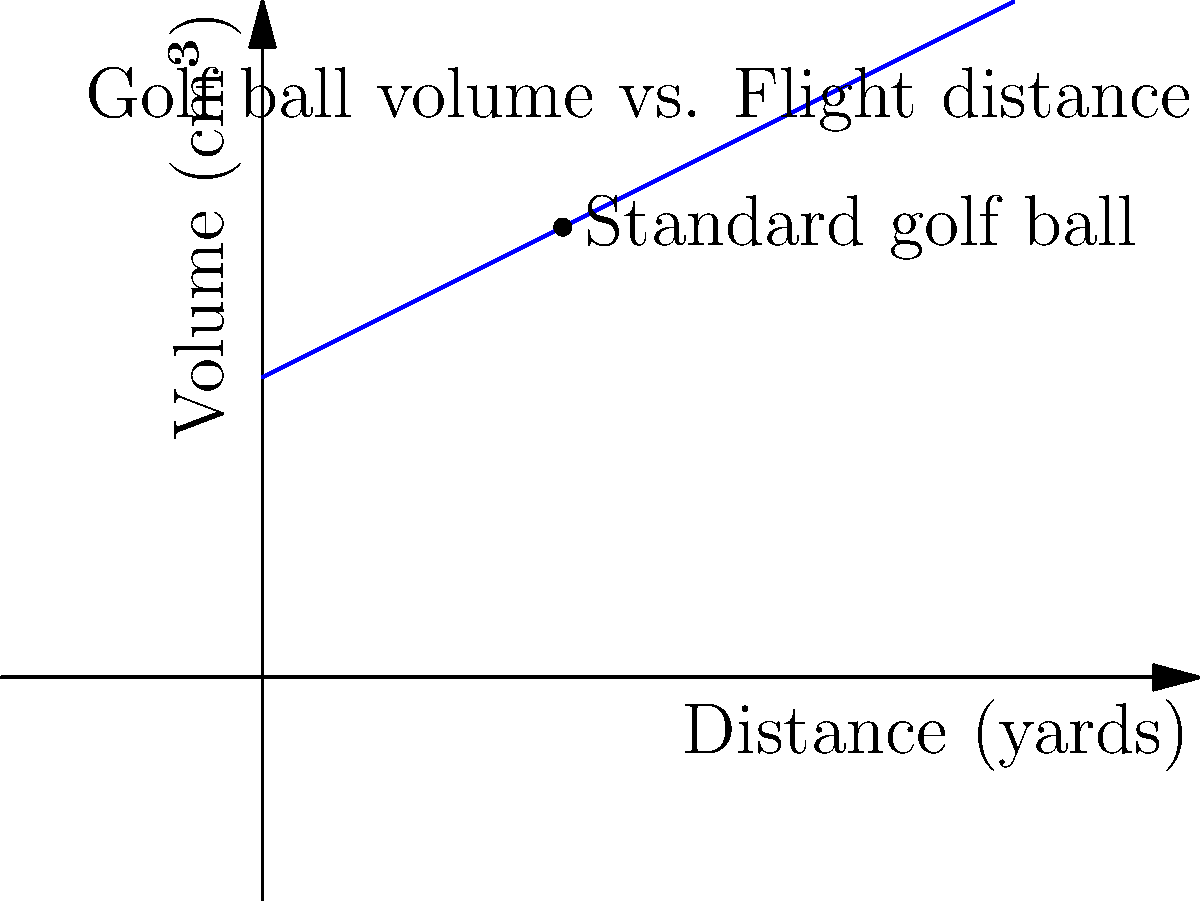As a professional golf enthusiast, you understand the importance of golf ball design. The graph shows the relationship between a golf ball's volume and its flight distance. If a standard golf ball has a volume of 40.68 cm³, what would be the approximate increase in flight distance (in yards) if the volume were increased to 45 cm³? Assume a linear relationship between volume and distance. To solve this problem, we'll follow these steps:

1) First, we need to identify the linear relationship between volume and distance from the graph. We can see that the line passes through the point (40, 60), which represents the standard golf ball.

2) We can use the point-slope form of a line to determine the equation:
   $y - y_1 = m(x - x_1)$
   Where $m$ is the slope, $(x_1, y_1)$ is a known point on the line.

3) From the graph, we can estimate that for every 1 cm³ increase in volume, the distance increases by about 2 yards. So the slope $m = 2$.

4) Using the point (40, 60) and slope 2, we can write the equation:
   $y - 60 = 2(x - 40)$

5) Simplify:
   $y = 2x - 20$

6) Now, we want to find the difference in y (distance) when x (volume) changes from 40.68 to 45 cm³.

7) For x = 40.68 cm³:
   $y_1 = 2(40.68) - 20 = 61.36$ yards

8) For x = 45 cm³:
   $y_2 = 2(45) - 20 = 70$ yards

9) The increase in distance is:
   $70 - 61.36 = 8.64$ yards

Therefore, the approximate increase in flight distance would be about 8.64 yards.
Answer: 8.64 yards 